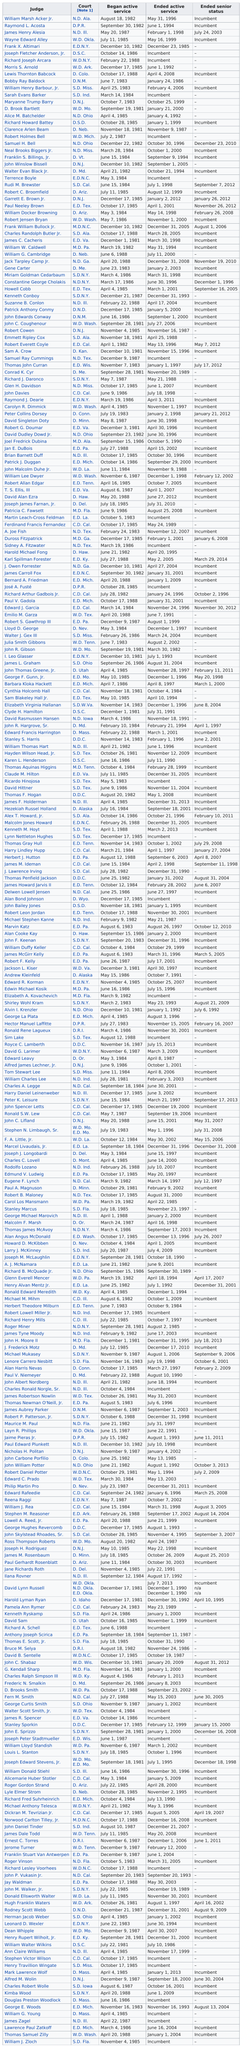Indicate a few pertinent items in this graphic. Joseph Fletcher Anderson, Jr. is the next judge listed after Frank X. Altimari. Wayne Edward Alley began active service before James Henry Alesia. Clarence Arlen Beam was preceded by Richard Howard Battey. I request to determine the total number of judges from the provided list that have served in the United States District Court for the Northern District of Ohio (N.D. Ohio). Specifically, I am seeking the number of judges who have been assigned to this court. Morris S. Arnold is ranked above Maryanne Trump Barry in the list. 